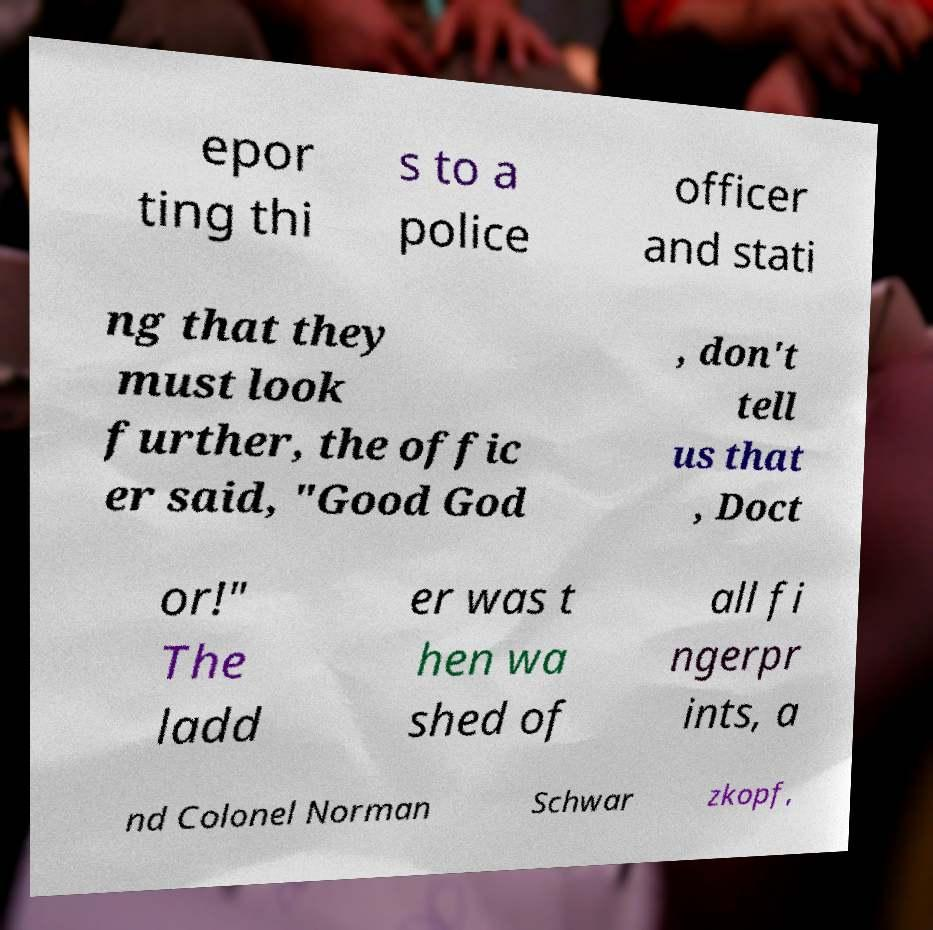For documentation purposes, I need the text within this image transcribed. Could you provide that? epor ting thi s to a police officer and stati ng that they must look further, the offic er said, "Good God , don't tell us that , Doct or!" The ladd er was t hen wa shed of all fi ngerpr ints, a nd Colonel Norman Schwar zkopf, 